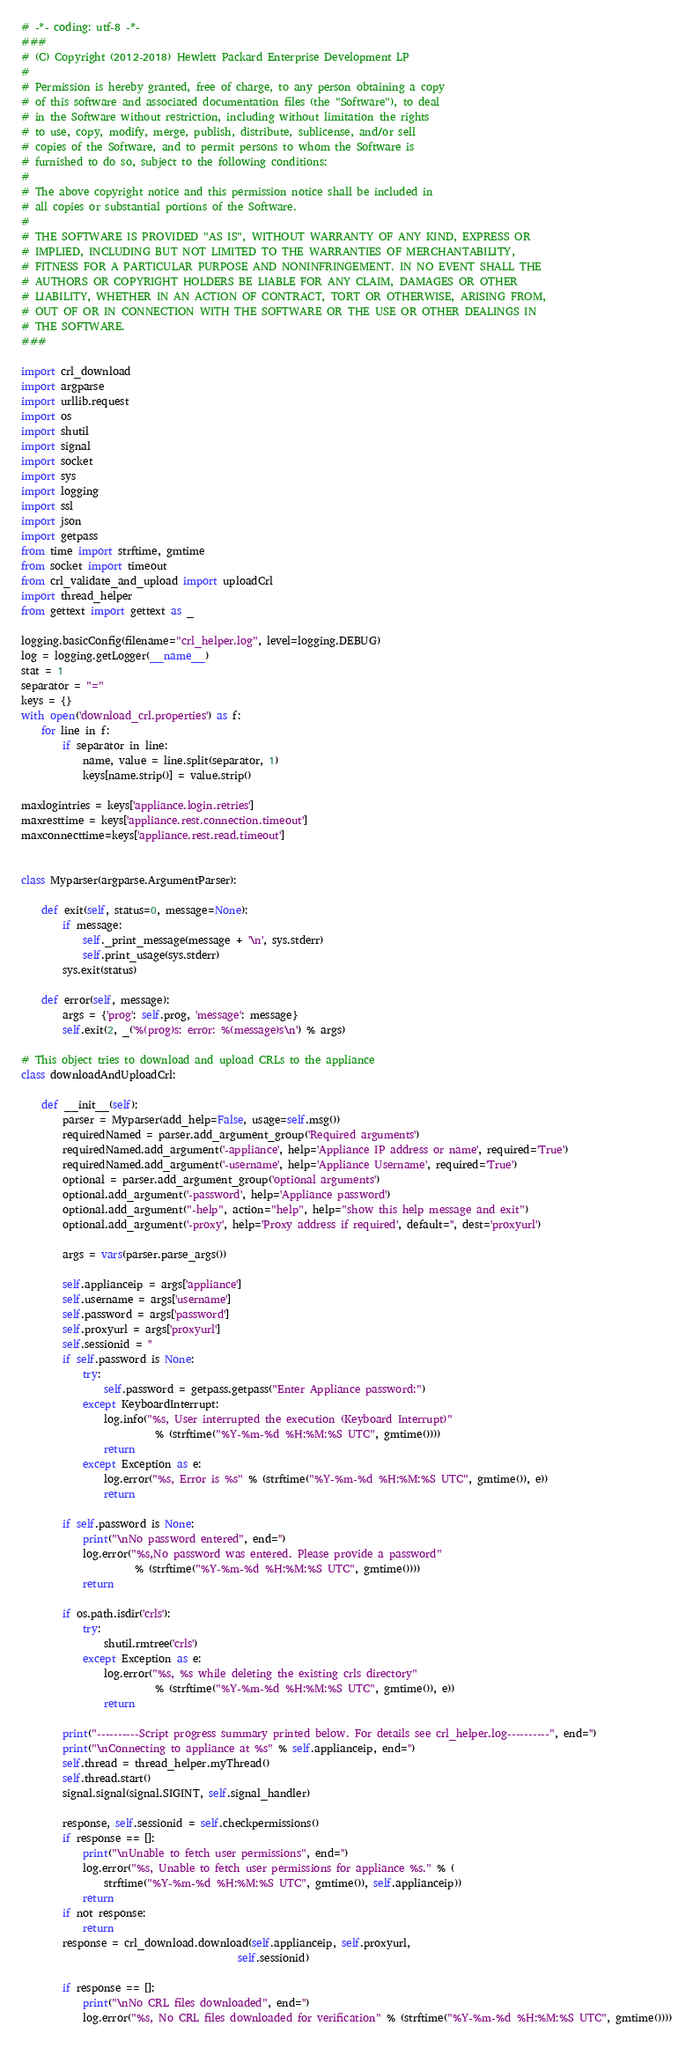<code> <loc_0><loc_0><loc_500><loc_500><_Python_># -*- coding: utf-8 -*-
###
# (C) Copyright (2012-2018) Hewlett Packard Enterprise Development LP
#
# Permission is hereby granted, free of charge, to any person obtaining a copy
# of this software and associated documentation files (the "Software"), to deal
# in the Software without restriction, including without limitation the rights
# to use, copy, modify, merge, publish, distribute, sublicense, and/or sell
# copies of the Software, and to permit persons to whom the Software is
# furnished to do so, subject to the following conditions:
#
# The above copyright notice and this permission notice shall be included in
# all copies or substantial portions of the Software.
#
# THE SOFTWARE IS PROVIDED "AS IS", WITHOUT WARRANTY OF ANY KIND, EXPRESS OR
# IMPLIED, INCLUDING BUT NOT LIMITED TO THE WARRANTIES OF MERCHANTABILITY,
# FITNESS FOR A PARTICULAR PURPOSE AND NONINFRINGEMENT. IN NO EVENT SHALL THE
# AUTHORS OR COPYRIGHT HOLDERS BE LIABLE FOR ANY CLAIM, DAMAGES OR OTHER
# LIABILITY, WHETHER IN AN ACTION OF CONTRACT, TORT OR OTHERWISE, ARISING FROM,
# OUT OF OR IN CONNECTION WITH THE SOFTWARE OR THE USE OR OTHER DEALINGS IN
# THE SOFTWARE.
###

import crl_download
import argparse
import urllib.request
import os
import shutil
import signal
import socket
import sys
import logging
import ssl
import json
import getpass
from time import strftime, gmtime
from socket import timeout
from crl_validate_and_upload import uploadCrl
import thread_helper
from gettext import gettext as _

logging.basicConfig(filename="crl_helper.log", level=logging.DEBUG)
log = logging.getLogger(__name__)
stat = 1
separator = "="
keys = {}
with open('download_crl.properties') as f:
    for line in f:
        if separator in line:
            name, value = line.split(separator, 1)
            keys[name.strip()] = value.strip()

maxlogintries = keys['appliance.login.retries']
maxresttime = keys['appliance.rest.connection.timeout']
maxconnecttime=keys['appliance.rest.read.timeout']


class Myparser(argparse.ArgumentParser):

    def exit(self, status=0, message=None):
        if message:
            self._print_message(message + '\n', sys.stderr)
            self.print_usage(sys.stderr)
        sys.exit(status)

    def error(self, message):
        args = {'prog': self.prog, 'message': message}
        self.exit(2, _('%(prog)s: error: %(message)s\n') % args)

# This object tries to download and upload CRLs to the appliance
class downloadAndUploadCrl:

    def __init__(self):
        parser = Myparser(add_help=False, usage=self.msg())
        requiredNamed = parser.add_argument_group('Required arguments')
        requiredNamed.add_argument('-appliance', help='Appliance IP address or name', required='True')
        requiredNamed.add_argument('-username', help='Appliance Username', required='True')
        optional = parser.add_argument_group('optional arguments')
        optional.add_argument('-password', help='Appliance password')
        optional.add_argument("-help", action="help", help="show this help message and exit")
        optional.add_argument('-proxy', help='Proxy address if required', default='', dest='proxyurl')

        args = vars(parser.parse_args())

        self.applianceip = args['appliance']
        self.username = args['username']
        self.password = args['password']
        self.proxyurl = args['proxyurl']
        self.sessionid = ''
        if self.password is None:
            try:
                self.password = getpass.getpass("Enter Appliance password:")
            except KeyboardInterrupt:
                log.info("%s, User interrupted the execution (Keyboard Interrupt)"
                          % (strftime("%Y-%m-%d %H:%M:%S UTC", gmtime())))
                return
            except Exception as e:
                log.error("%s, Error is %s" % (strftime("%Y-%m-%d %H:%M:%S UTC", gmtime()), e))
                return

        if self.password is None:
            print("\nNo password entered", end='')
            log.error("%s,No password was entered. Please provide a password"
                      % (strftime("%Y-%m-%d %H:%M:%S UTC", gmtime())))
            return

        if os.path.isdir('crls'):
            try:
                shutil.rmtree('crls')
            except Exception as e:
                log.error("%s, %s while deleting the existing crls directory"
                          % (strftime("%Y-%m-%d %H:%M:%S UTC", gmtime()), e))
                return

        print("----------Script progress summary printed below. For details see crl_helper.log----------", end='')
        print("\nConnecting to appliance at %s" % self.applianceip, end='')
        self.thread = thread_helper.myThread()
        self.thread.start()
        signal.signal(signal.SIGINT, self.signal_handler)

        response, self.sessionid = self.checkpermissions()
        if response == []:
            print("\nUnable to fetch user permissions", end='')
            log.error("%s, Unable to fetch user permissions for appliance %s." % (
                strftime("%Y-%m-%d %H:%M:%S UTC", gmtime()), self.applianceip))
            return
        if not response:
            return
        response = crl_download.download(self.applianceip, self.proxyurl,
                                          self.sessionid)

        if response == []:
            print("\nNo CRL files downloaded", end='')
            log.error("%s, No CRL files downloaded for verification" % (strftime("%Y-%m-%d %H:%M:%S UTC", gmtime())))</code> 